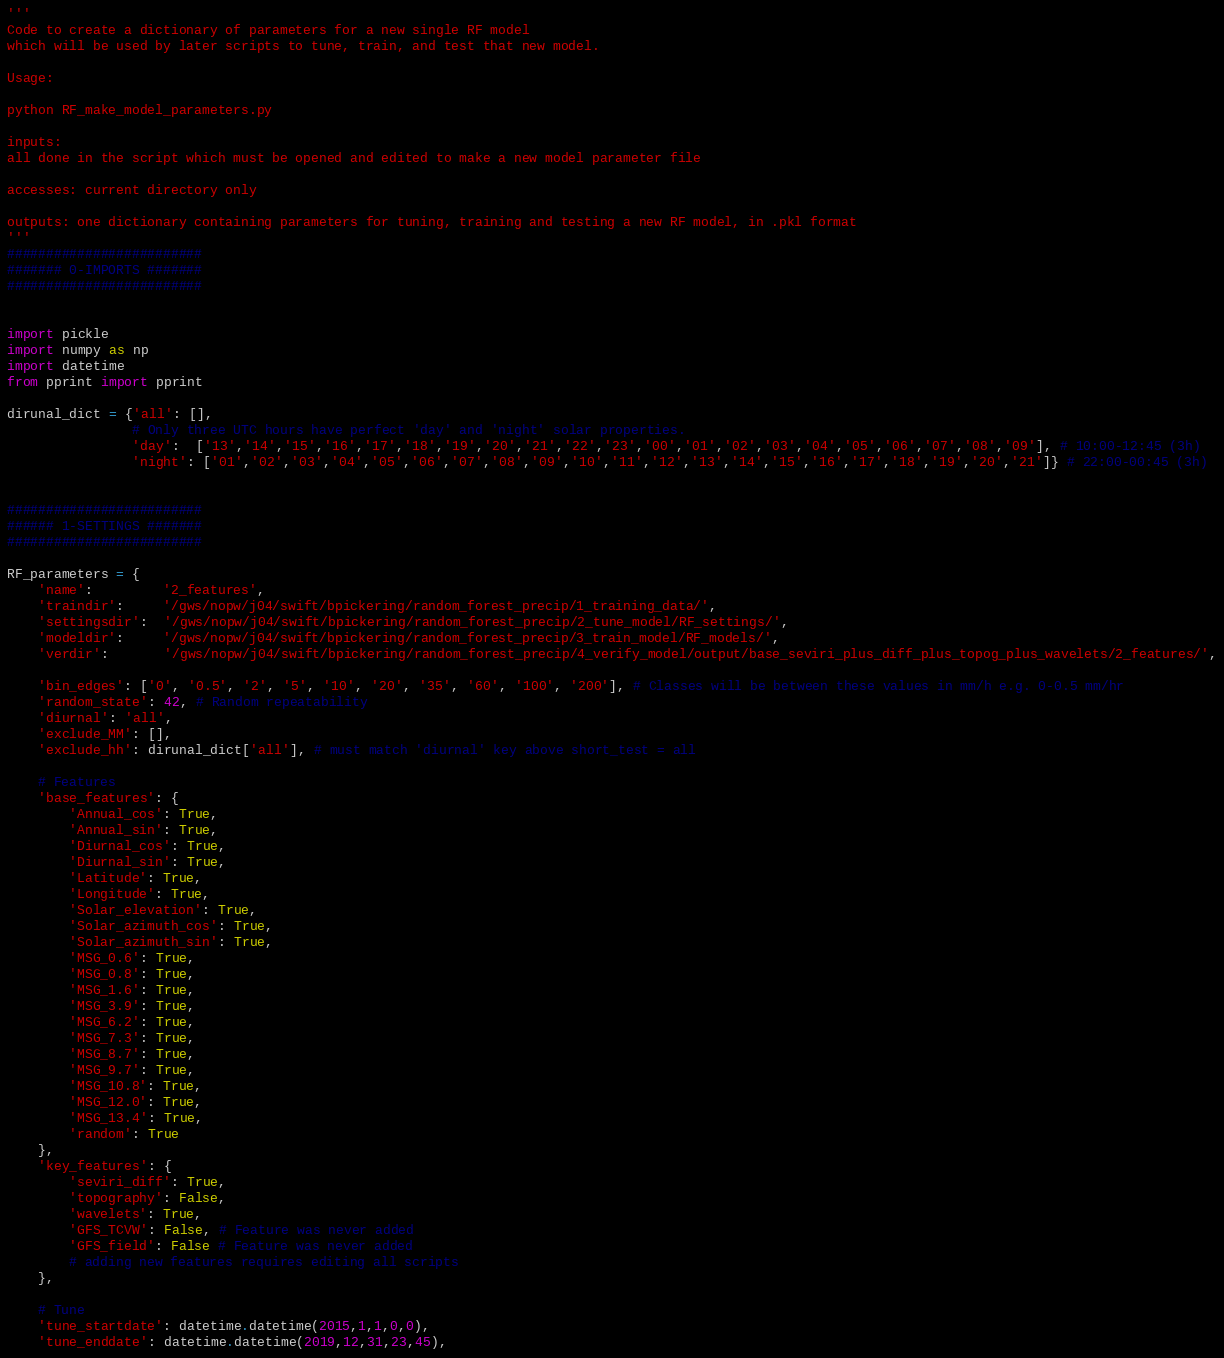Convert code to text. <code><loc_0><loc_0><loc_500><loc_500><_Python_>'''
Code to create a dictionary of parameters for a new single RF model 
which will be used by later scripts to tune, train, and test that new model.

Usage:

python RF_make_model_parameters.py

inputs:
all done in the script which must be opened and edited to make a new model parameter file

accesses: current directory only

outputs: one dictionary containing parameters for tuning, training and testing a new RF model, in .pkl format
'''
#########################
####### 0-IMPORTS #######
#########################


import pickle
import numpy as np
import datetime
from pprint import pprint

dirunal_dict = {'all': [],
                # Only three UTC hours have perfect 'day' and 'night' solar properties.
                'day':  ['13','14','15','16','17','18','19','20','21','22','23','00','01','02','03','04','05','06','07','08','09'], # 10:00-12:45 (3h)
                'night': ['01','02','03','04','05','06','07','08','09','10','11','12','13','14','15','16','17','18','19','20','21']} # 22:00-00:45 (3h)


#########################
###### 1-SETTINGS #######
######################### 

RF_parameters = {
    'name':         '2_features',
    'traindir':     '/gws/nopw/j04/swift/bpickering/random_forest_precip/1_training_data/',
    'settingsdir':  '/gws/nopw/j04/swift/bpickering/random_forest_precip/2_tune_model/RF_settings/',
    'modeldir':     '/gws/nopw/j04/swift/bpickering/random_forest_precip/3_train_model/RF_models/',
    'verdir':       '/gws/nopw/j04/swift/bpickering/random_forest_precip/4_verify_model/output/base_seviri_plus_diff_plus_topog_plus_wavelets/2_features/',
    
    'bin_edges': ['0', '0.5', '2', '5', '10', '20', '35', '60', '100', '200'], # Classes will be between these values in mm/h e.g. 0-0.5 mm/hr
    'random_state': 42, # Random repeatability
    'diurnal': 'all',
    'exclude_MM': [],
    'exclude_hh': dirunal_dict['all'], # must match 'diurnal' key above short_test = all
    
    # Features
    'base_features': {
        'Annual_cos': True,
        'Annual_sin': True,
        'Diurnal_cos': True,
        'Diurnal_sin': True,
        'Latitude': True,
        'Longitude': True,
        'Solar_elevation': True,
        'Solar_azimuth_cos': True,
        'Solar_azimuth_sin': True,
        'MSG_0.6': True,
        'MSG_0.8': True,
        'MSG_1.6': True,
        'MSG_3.9': True,
        'MSG_6.2': True,
        'MSG_7.3': True,
        'MSG_8.7': True,
        'MSG_9.7': True,
        'MSG_10.8': True,
        'MSG_12.0': True,
        'MSG_13.4': True,
        'random': True
    },
    'key_features': { 
        'seviri_diff': True,
        'topography': False,
        'wavelets': True,
        'GFS_TCVW': False, # Feature was never added
        'GFS_field': False # Feature was never added
        # adding new features requires editing all scripts
    },
    
    # Tune
    'tune_startdate': datetime.datetime(2015,1,1,0,0),
    'tune_enddate': datetime.datetime(2019,12,31,23,45),</code> 